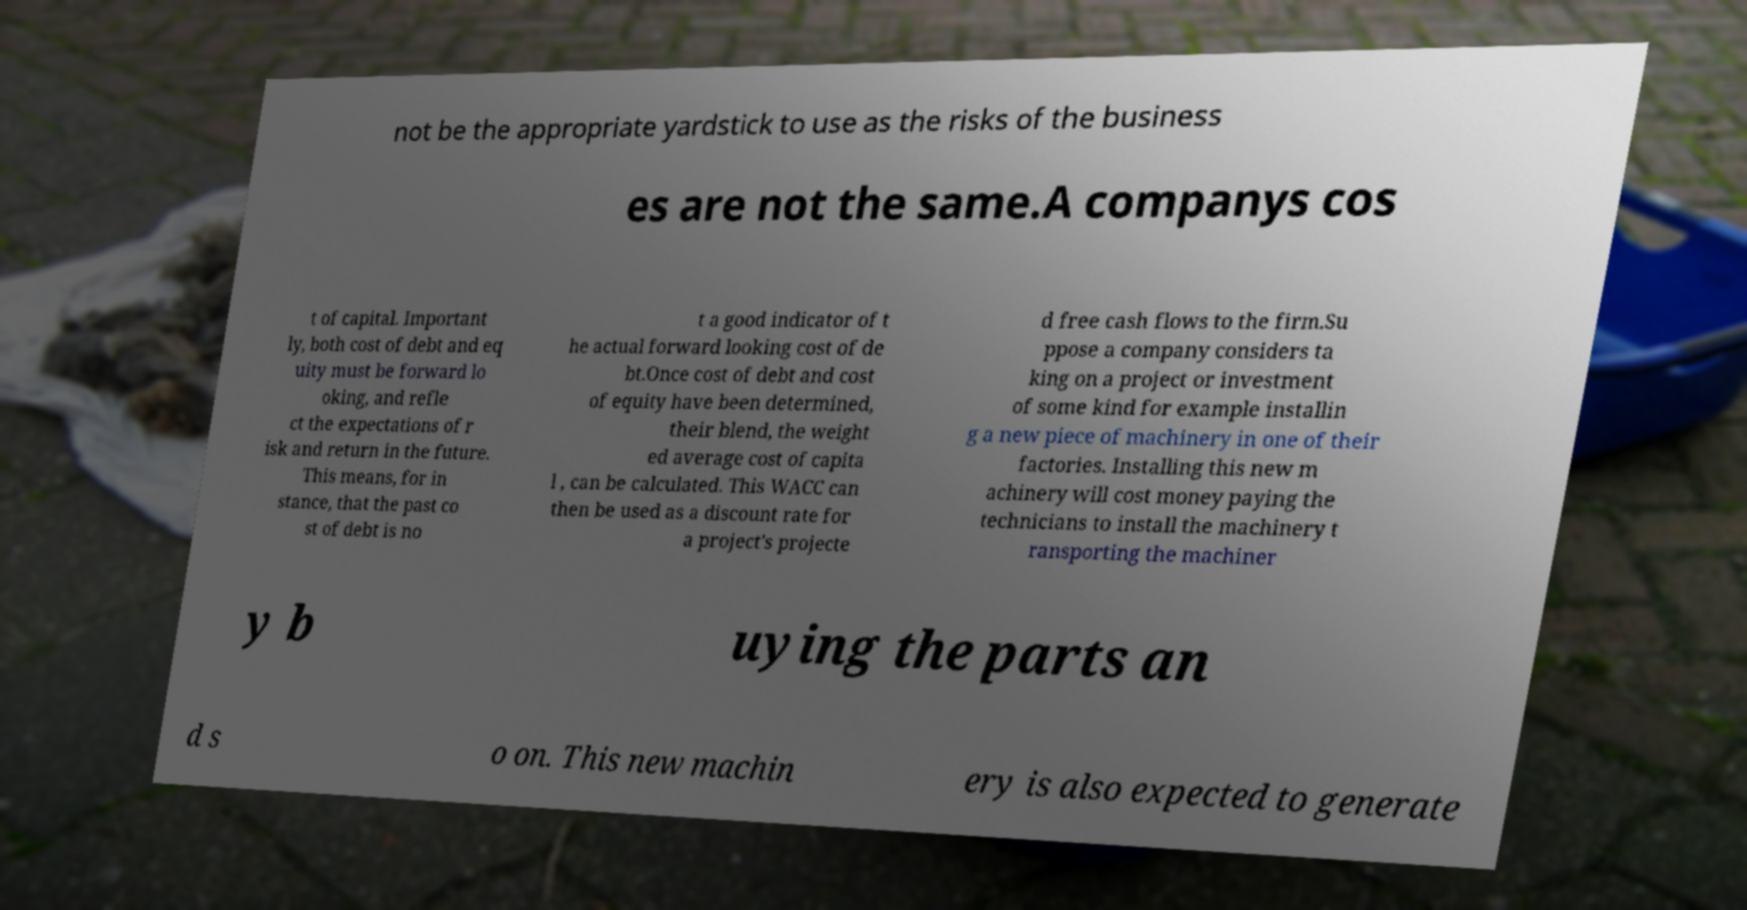Please identify and transcribe the text found in this image. not be the appropriate yardstick to use as the risks of the business es are not the same.A companys cos t of capital. Important ly, both cost of debt and eq uity must be forward lo oking, and refle ct the expectations of r isk and return in the future. This means, for in stance, that the past co st of debt is no t a good indicator of t he actual forward looking cost of de bt.Once cost of debt and cost of equity have been determined, their blend, the weight ed average cost of capita l , can be calculated. This WACC can then be used as a discount rate for a project's projecte d free cash flows to the firm.Su ppose a company considers ta king on a project or investment of some kind for example installin g a new piece of machinery in one of their factories. Installing this new m achinery will cost money paying the technicians to install the machinery t ransporting the machiner y b uying the parts an d s o on. This new machin ery is also expected to generate 